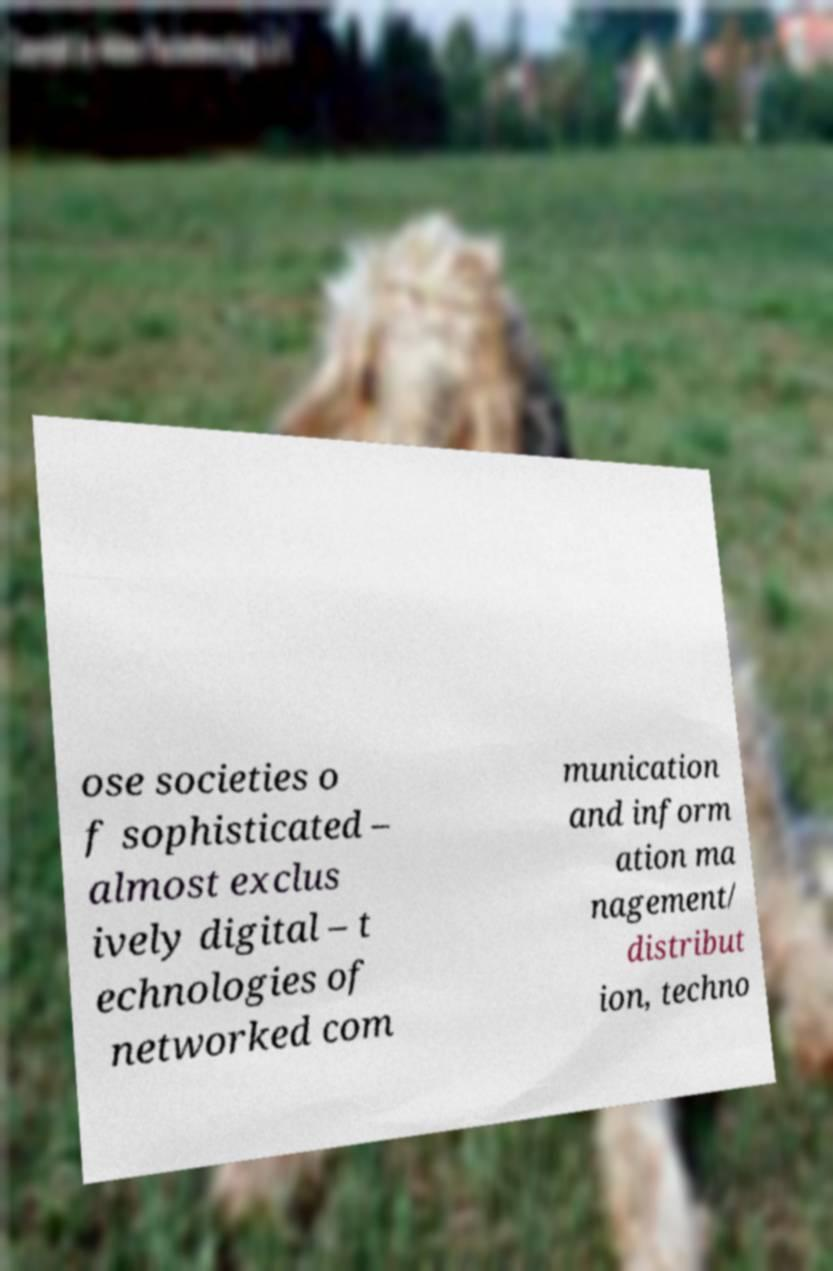There's text embedded in this image that I need extracted. Can you transcribe it verbatim? ose societies o f sophisticated – almost exclus ively digital – t echnologies of networked com munication and inform ation ma nagement/ distribut ion, techno 